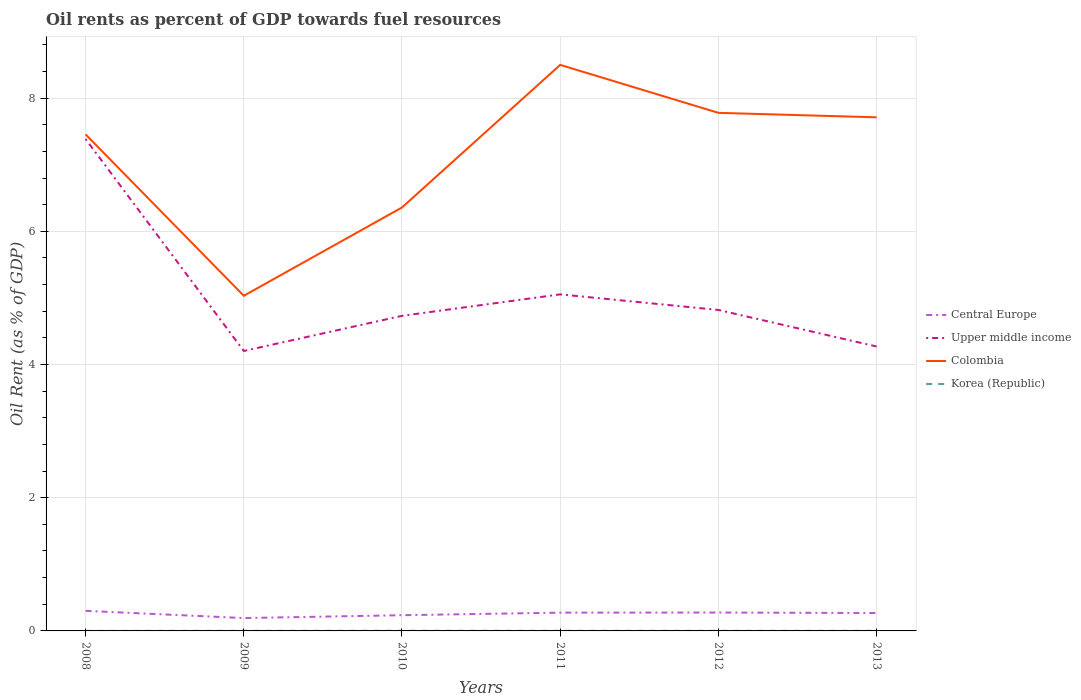How many different coloured lines are there?
Offer a very short reply. 4. Does the line corresponding to Colombia intersect with the line corresponding to Upper middle income?
Provide a short and direct response. No. Is the number of lines equal to the number of legend labels?
Ensure brevity in your answer.  Yes. Across all years, what is the maximum oil rent in Central Europe?
Provide a succinct answer. 0.19. In which year was the oil rent in Korea (Republic) maximum?
Provide a succinct answer. 2008. What is the total oil rent in Central Europe in the graph?
Your response must be concise. 0.01. What is the difference between the highest and the second highest oil rent in Korea (Republic)?
Provide a short and direct response. 0. What is the difference between the highest and the lowest oil rent in Central Europe?
Offer a very short reply. 4. Is the oil rent in Upper middle income strictly greater than the oil rent in Korea (Republic) over the years?
Your answer should be very brief. No. Are the values on the major ticks of Y-axis written in scientific E-notation?
Provide a succinct answer. No. Does the graph contain any zero values?
Ensure brevity in your answer.  No. How many legend labels are there?
Keep it short and to the point. 4. How are the legend labels stacked?
Provide a short and direct response. Vertical. What is the title of the graph?
Make the answer very short. Oil rents as percent of GDP towards fuel resources. Does "Benin" appear as one of the legend labels in the graph?
Provide a short and direct response. No. What is the label or title of the X-axis?
Your response must be concise. Years. What is the label or title of the Y-axis?
Your answer should be compact. Oil Rent (as % of GDP). What is the Oil Rent (as % of GDP) of Central Europe in 2008?
Provide a short and direct response. 0.3. What is the Oil Rent (as % of GDP) of Upper middle income in 2008?
Offer a very short reply. 7.39. What is the Oil Rent (as % of GDP) of Colombia in 2008?
Offer a very short reply. 7.46. What is the Oil Rent (as % of GDP) in Korea (Republic) in 2008?
Make the answer very short. 0. What is the Oil Rent (as % of GDP) in Central Europe in 2009?
Offer a terse response. 0.19. What is the Oil Rent (as % of GDP) in Upper middle income in 2009?
Ensure brevity in your answer.  4.2. What is the Oil Rent (as % of GDP) in Colombia in 2009?
Your response must be concise. 5.03. What is the Oil Rent (as % of GDP) of Korea (Republic) in 2009?
Provide a short and direct response. 0. What is the Oil Rent (as % of GDP) of Central Europe in 2010?
Your answer should be compact. 0.24. What is the Oil Rent (as % of GDP) in Upper middle income in 2010?
Provide a short and direct response. 4.73. What is the Oil Rent (as % of GDP) in Colombia in 2010?
Your answer should be compact. 6.36. What is the Oil Rent (as % of GDP) of Korea (Republic) in 2010?
Your answer should be very brief. 0. What is the Oil Rent (as % of GDP) in Central Europe in 2011?
Your response must be concise. 0.27. What is the Oil Rent (as % of GDP) of Upper middle income in 2011?
Provide a short and direct response. 5.05. What is the Oil Rent (as % of GDP) of Colombia in 2011?
Ensure brevity in your answer.  8.5. What is the Oil Rent (as % of GDP) of Korea (Republic) in 2011?
Offer a very short reply. 0. What is the Oil Rent (as % of GDP) in Central Europe in 2012?
Provide a short and direct response. 0.28. What is the Oil Rent (as % of GDP) in Upper middle income in 2012?
Your response must be concise. 4.82. What is the Oil Rent (as % of GDP) of Colombia in 2012?
Offer a terse response. 7.78. What is the Oil Rent (as % of GDP) of Korea (Republic) in 2012?
Make the answer very short. 0. What is the Oil Rent (as % of GDP) of Central Europe in 2013?
Offer a very short reply. 0.27. What is the Oil Rent (as % of GDP) in Upper middle income in 2013?
Your answer should be very brief. 4.27. What is the Oil Rent (as % of GDP) of Colombia in 2013?
Ensure brevity in your answer.  7.71. What is the Oil Rent (as % of GDP) of Korea (Republic) in 2013?
Your answer should be very brief. 0. Across all years, what is the maximum Oil Rent (as % of GDP) in Central Europe?
Your answer should be very brief. 0.3. Across all years, what is the maximum Oil Rent (as % of GDP) in Upper middle income?
Keep it short and to the point. 7.39. Across all years, what is the maximum Oil Rent (as % of GDP) in Colombia?
Offer a very short reply. 8.5. Across all years, what is the maximum Oil Rent (as % of GDP) of Korea (Republic)?
Provide a short and direct response. 0. Across all years, what is the minimum Oil Rent (as % of GDP) in Central Europe?
Keep it short and to the point. 0.19. Across all years, what is the minimum Oil Rent (as % of GDP) of Upper middle income?
Provide a succinct answer. 4.2. Across all years, what is the minimum Oil Rent (as % of GDP) in Colombia?
Your answer should be compact. 5.03. Across all years, what is the minimum Oil Rent (as % of GDP) in Korea (Republic)?
Offer a terse response. 0. What is the total Oil Rent (as % of GDP) of Central Europe in the graph?
Give a very brief answer. 1.55. What is the total Oil Rent (as % of GDP) of Upper middle income in the graph?
Your response must be concise. 30.46. What is the total Oil Rent (as % of GDP) in Colombia in the graph?
Your response must be concise. 42.83. What is the total Oil Rent (as % of GDP) in Korea (Republic) in the graph?
Offer a very short reply. 0.01. What is the difference between the Oil Rent (as % of GDP) in Central Europe in 2008 and that in 2009?
Offer a very short reply. 0.11. What is the difference between the Oil Rent (as % of GDP) in Upper middle income in 2008 and that in 2009?
Provide a short and direct response. 3.18. What is the difference between the Oil Rent (as % of GDP) in Colombia in 2008 and that in 2009?
Your answer should be very brief. 2.42. What is the difference between the Oil Rent (as % of GDP) of Korea (Republic) in 2008 and that in 2009?
Provide a short and direct response. -0. What is the difference between the Oil Rent (as % of GDP) of Central Europe in 2008 and that in 2010?
Offer a terse response. 0.07. What is the difference between the Oil Rent (as % of GDP) of Upper middle income in 2008 and that in 2010?
Your answer should be very brief. 2.65. What is the difference between the Oil Rent (as % of GDP) of Colombia in 2008 and that in 2010?
Give a very brief answer. 1.1. What is the difference between the Oil Rent (as % of GDP) in Korea (Republic) in 2008 and that in 2010?
Your answer should be very brief. -0. What is the difference between the Oil Rent (as % of GDP) in Central Europe in 2008 and that in 2011?
Your answer should be compact. 0.03. What is the difference between the Oil Rent (as % of GDP) of Upper middle income in 2008 and that in 2011?
Your answer should be very brief. 2.33. What is the difference between the Oil Rent (as % of GDP) in Colombia in 2008 and that in 2011?
Ensure brevity in your answer.  -1.04. What is the difference between the Oil Rent (as % of GDP) in Korea (Republic) in 2008 and that in 2011?
Keep it short and to the point. -0. What is the difference between the Oil Rent (as % of GDP) of Central Europe in 2008 and that in 2012?
Give a very brief answer. 0.03. What is the difference between the Oil Rent (as % of GDP) of Upper middle income in 2008 and that in 2012?
Offer a terse response. 2.57. What is the difference between the Oil Rent (as % of GDP) of Colombia in 2008 and that in 2012?
Offer a very short reply. -0.32. What is the difference between the Oil Rent (as % of GDP) in Korea (Republic) in 2008 and that in 2012?
Your response must be concise. -0. What is the difference between the Oil Rent (as % of GDP) of Central Europe in 2008 and that in 2013?
Keep it short and to the point. 0.03. What is the difference between the Oil Rent (as % of GDP) of Upper middle income in 2008 and that in 2013?
Make the answer very short. 3.12. What is the difference between the Oil Rent (as % of GDP) of Colombia in 2008 and that in 2013?
Ensure brevity in your answer.  -0.26. What is the difference between the Oil Rent (as % of GDP) in Korea (Republic) in 2008 and that in 2013?
Offer a terse response. -0. What is the difference between the Oil Rent (as % of GDP) in Central Europe in 2009 and that in 2010?
Your answer should be compact. -0.04. What is the difference between the Oil Rent (as % of GDP) in Upper middle income in 2009 and that in 2010?
Provide a succinct answer. -0.53. What is the difference between the Oil Rent (as % of GDP) in Colombia in 2009 and that in 2010?
Provide a short and direct response. -1.33. What is the difference between the Oil Rent (as % of GDP) in Korea (Republic) in 2009 and that in 2010?
Offer a very short reply. -0. What is the difference between the Oil Rent (as % of GDP) in Central Europe in 2009 and that in 2011?
Give a very brief answer. -0.08. What is the difference between the Oil Rent (as % of GDP) in Upper middle income in 2009 and that in 2011?
Offer a very short reply. -0.85. What is the difference between the Oil Rent (as % of GDP) of Colombia in 2009 and that in 2011?
Give a very brief answer. -3.47. What is the difference between the Oil Rent (as % of GDP) of Korea (Republic) in 2009 and that in 2011?
Give a very brief answer. -0. What is the difference between the Oil Rent (as % of GDP) in Central Europe in 2009 and that in 2012?
Your response must be concise. -0.08. What is the difference between the Oil Rent (as % of GDP) in Upper middle income in 2009 and that in 2012?
Provide a succinct answer. -0.62. What is the difference between the Oil Rent (as % of GDP) in Colombia in 2009 and that in 2012?
Give a very brief answer. -2.75. What is the difference between the Oil Rent (as % of GDP) in Korea (Republic) in 2009 and that in 2012?
Provide a short and direct response. -0. What is the difference between the Oil Rent (as % of GDP) of Central Europe in 2009 and that in 2013?
Give a very brief answer. -0.08. What is the difference between the Oil Rent (as % of GDP) of Upper middle income in 2009 and that in 2013?
Offer a very short reply. -0.07. What is the difference between the Oil Rent (as % of GDP) in Colombia in 2009 and that in 2013?
Provide a succinct answer. -2.68. What is the difference between the Oil Rent (as % of GDP) in Korea (Republic) in 2009 and that in 2013?
Offer a terse response. -0. What is the difference between the Oil Rent (as % of GDP) of Central Europe in 2010 and that in 2011?
Give a very brief answer. -0.04. What is the difference between the Oil Rent (as % of GDP) of Upper middle income in 2010 and that in 2011?
Give a very brief answer. -0.32. What is the difference between the Oil Rent (as % of GDP) in Colombia in 2010 and that in 2011?
Your answer should be very brief. -2.14. What is the difference between the Oil Rent (as % of GDP) of Central Europe in 2010 and that in 2012?
Provide a short and direct response. -0.04. What is the difference between the Oil Rent (as % of GDP) in Upper middle income in 2010 and that in 2012?
Give a very brief answer. -0.09. What is the difference between the Oil Rent (as % of GDP) in Colombia in 2010 and that in 2012?
Make the answer very short. -1.42. What is the difference between the Oil Rent (as % of GDP) in Korea (Republic) in 2010 and that in 2012?
Your answer should be very brief. 0. What is the difference between the Oil Rent (as % of GDP) in Central Europe in 2010 and that in 2013?
Keep it short and to the point. -0.03. What is the difference between the Oil Rent (as % of GDP) of Upper middle income in 2010 and that in 2013?
Keep it short and to the point. 0.46. What is the difference between the Oil Rent (as % of GDP) in Colombia in 2010 and that in 2013?
Your answer should be compact. -1.35. What is the difference between the Oil Rent (as % of GDP) of Korea (Republic) in 2010 and that in 2013?
Provide a short and direct response. 0. What is the difference between the Oil Rent (as % of GDP) of Central Europe in 2011 and that in 2012?
Offer a very short reply. -0. What is the difference between the Oil Rent (as % of GDP) of Upper middle income in 2011 and that in 2012?
Your answer should be compact. 0.23. What is the difference between the Oil Rent (as % of GDP) in Colombia in 2011 and that in 2012?
Offer a very short reply. 0.72. What is the difference between the Oil Rent (as % of GDP) in Korea (Republic) in 2011 and that in 2012?
Ensure brevity in your answer.  0. What is the difference between the Oil Rent (as % of GDP) in Central Europe in 2011 and that in 2013?
Your response must be concise. 0.01. What is the difference between the Oil Rent (as % of GDP) of Upper middle income in 2011 and that in 2013?
Give a very brief answer. 0.78. What is the difference between the Oil Rent (as % of GDP) of Colombia in 2011 and that in 2013?
Give a very brief answer. 0.79. What is the difference between the Oil Rent (as % of GDP) in Korea (Republic) in 2011 and that in 2013?
Offer a very short reply. 0. What is the difference between the Oil Rent (as % of GDP) in Central Europe in 2012 and that in 2013?
Offer a very short reply. 0.01. What is the difference between the Oil Rent (as % of GDP) of Upper middle income in 2012 and that in 2013?
Offer a terse response. 0.55. What is the difference between the Oil Rent (as % of GDP) of Colombia in 2012 and that in 2013?
Ensure brevity in your answer.  0.07. What is the difference between the Oil Rent (as % of GDP) of Central Europe in 2008 and the Oil Rent (as % of GDP) of Upper middle income in 2009?
Offer a very short reply. -3.9. What is the difference between the Oil Rent (as % of GDP) of Central Europe in 2008 and the Oil Rent (as % of GDP) of Colombia in 2009?
Provide a short and direct response. -4.73. What is the difference between the Oil Rent (as % of GDP) in Central Europe in 2008 and the Oil Rent (as % of GDP) in Korea (Republic) in 2009?
Provide a short and direct response. 0.3. What is the difference between the Oil Rent (as % of GDP) in Upper middle income in 2008 and the Oil Rent (as % of GDP) in Colombia in 2009?
Make the answer very short. 2.35. What is the difference between the Oil Rent (as % of GDP) of Upper middle income in 2008 and the Oil Rent (as % of GDP) of Korea (Republic) in 2009?
Your answer should be compact. 7.38. What is the difference between the Oil Rent (as % of GDP) of Colombia in 2008 and the Oil Rent (as % of GDP) of Korea (Republic) in 2009?
Ensure brevity in your answer.  7.45. What is the difference between the Oil Rent (as % of GDP) of Central Europe in 2008 and the Oil Rent (as % of GDP) of Upper middle income in 2010?
Make the answer very short. -4.43. What is the difference between the Oil Rent (as % of GDP) of Central Europe in 2008 and the Oil Rent (as % of GDP) of Colombia in 2010?
Provide a short and direct response. -6.06. What is the difference between the Oil Rent (as % of GDP) of Central Europe in 2008 and the Oil Rent (as % of GDP) of Korea (Republic) in 2010?
Your answer should be compact. 0.3. What is the difference between the Oil Rent (as % of GDP) of Upper middle income in 2008 and the Oil Rent (as % of GDP) of Colombia in 2010?
Your response must be concise. 1.03. What is the difference between the Oil Rent (as % of GDP) in Upper middle income in 2008 and the Oil Rent (as % of GDP) in Korea (Republic) in 2010?
Your answer should be very brief. 7.38. What is the difference between the Oil Rent (as % of GDP) of Colombia in 2008 and the Oil Rent (as % of GDP) of Korea (Republic) in 2010?
Give a very brief answer. 7.45. What is the difference between the Oil Rent (as % of GDP) of Central Europe in 2008 and the Oil Rent (as % of GDP) of Upper middle income in 2011?
Give a very brief answer. -4.75. What is the difference between the Oil Rent (as % of GDP) of Central Europe in 2008 and the Oil Rent (as % of GDP) of Colombia in 2011?
Keep it short and to the point. -8.2. What is the difference between the Oil Rent (as % of GDP) in Central Europe in 2008 and the Oil Rent (as % of GDP) in Korea (Republic) in 2011?
Provide a short and direct response. 0.3. What is the difference between the Oil Rent (as % of GDP) of Upper middle income in 2008 and the Oil Rent (as % of GDP) of Colombia in 2011?
Ensure brevity in your answer.  -1.11. What is the difference between the Oil Rent (as % of GDP) in Upper middle income in 2008 and the Oil Rent (as % of GDP) in Korea (Republic) in 2011?
Your answer should be compact. 7.38. What is the difference between the Oil Rent (as % of GDP) of Colombia in 2008 and the Oil Rent (as % of GDP) of Korea (Republic) in 2011?
Your answer should be very brief. 7.45. What is the difference between the Oil Rent (as % of GDP) of Central Europe in 2008 and the Oil Rent (as % of GDP) of Upper middle income in 2012?
Provide a succinct answer. -4.52. What is the difference between the Oil Rent (as % of GDP) in Central Europe in 2008 and the Oil Rent (as % of GDP) in Colombia in 2012?
Offer a very short reply. -7.48. What is the difference between the Oil Rent (as % of GDP) in Central Europe in 2008 and the Oil Rent (as % of GDP) in Korea (Republic) in 2012?
Provide a succinct answer. 0.3. What is the difference between the Oil Rent (as % of GDP) of Upper middle income in 2008 and the Oil Rent (as % of GDP) of Colombia in 2012?
Ensure brevity in your answer.  -0.39. What is the difference between the Oil Rent (as % of GDP) in Upper middle income in 2008 and the Oil Rent (as % of GDP) in Korea (Republic) in 2012?
Provide a short and direct response. 7.38. What is the difference between the Oil Rent (as % of GDP) in Colombia in 2008 and the Oil Rent (as % of GDP) in Korea (Republic) in 2012?
Provide a succinct answer. 7.45. What is the difference between the Oil Rent (as % of GDP) in Central Europe in 2008 and the Oil Rent (as % of GDP) in Upper middle income in 2013?
Your answer should be compact. -3.97. What is the difference between the Oil Rent (as % of GDP) in Central Europe in 2008 and the Oil Rent (as % of GDP) in Colombia in 2013?
Your response must be concise. -7.41. What is the difference between the Oil Rent (as % of GDP) in Central Europe in 2008 and the Oil Rent (as % of GDP) in Korea (Republic) in 2013?
Provide a succinct answer. 0.3. What is the difference between the Oil Rent (as % of GDP) in Upper middle income in 2008 and the Oil Rent (as % of GDP) in Colombia in 2013?
Keep it short and to the point. -0.33. What is the difference between the Oil Rent (as % of GDP) in Upper middle income in 2008 and the Oil Rent (as % of GDP) in Korea (Republic) in 2013?
Provide a succinct answer. 7.38. What is the difference between the Oil Rent (as % of GDP) of Colombia in 2008 and the Oil Rent (as % of GDP) of Korea (Republic) in 2013?
Offer a very short reply. 7.45. What is the difference between the Oil Rent (as % of GDP) of Central Europe in 2009 and the Oil Rent (as % of GDP) of Upper middle income in 2010?
Make the answer very short. -4.54. What is the difference between the Oil Rent (as % of GDP) in Central Europe in 2009 and the Oil Rent (as % of GDP) in Colombia in 2010?
Offer a terse response. -6.16. What is the difference between the Oil Rent (as % of GDP) in Central Europe in 2009 and the Oil Rent (as % of GDP) in Korea (Republic) in 2010?
Give a very brief answer. 0.19. What is the difference between the Oil Rent (as % of GDP) in Upper middle income in 2009 and the Oil Rent (as % of GDP) in Colombia in 2010?
Keep it short and to the point. -2.15. What is the difference between the Oil Rent (as % of GDP) in Upper middle income in 2009 and the Oil Rent (as % of GDP) in Korea (Republic) in 2010?
Offer a very short reply. 4.2. What is the difference between the Oil Rent (as % of GDP) in Colombia in 2009 and the Oil Rent (as % of GDP) in Korea (Republic) in 2010?
Your response must be concise. 5.03. What is the difference between the Oil Rent (as % of GDP) of Central Europe in 2009 and the Oil Rent (as % of GDP) of Upper middle income in 2011?
Provide a short and direct response. -4.86. What is the difference between the Oil Rent (as % of GDP) in Central Europe in 2009 and the Oil Rent (as % of GDP) in Colombia in 2011?
Give a very brief answer. -8.31. What is the difference between the Oil Rent (as % of GDP) in Central Europe in 2009 and the Oil Rent (as % of GDP) in Korea (Republic) in 2011?
Ensure brevity in your answer.  0.19. What is the difference between the Oil Rent (as % of GDP) in Upper middle income in 2009 and the Oil Rent (as % of GDP) in Colombia in 2011?
Offer a very short reply. -4.3. What is the difference between the Oil Rent (as % of GDP) in Upper middle income in 2009 and the Oil Rent (as % of GDP) in Korea (Republic) in 2011?
Ensure brevity in your answer.  4.2. What is the difference between the Oil Rent (as % of GDP) in Colombia in 2009 and the Oil Rent (as % of GDP) in Korea (Republic) in 2011?
Offer a terse response. 5.03. What is the difference between the Oil Rent (as % of GDP) in Central Europe in 2009 and the Oil Rent (as % of GDP) in Upper middle income in 2012?
Give a very brief answer. -4.63. What is the difference between the Oil Rent (as % of GDP) of Central Europe in 2009 and the Oil Rent (as % of GDP) of Colombia in 2012?
Make the answer very short. -7.59. What is the difference between the Oil Rent (as % of GDP) of Central Europe in 2009 and the Oil Rent (as % of GDP) of Korea (Republic) in 2012?
Give a very brief answer. 0.19. What is the difference between the Oil Rent (as % of GDP) in Upper middle income in 2009 and the Oil Rent (as % of GDP) in Colombia in 2012?
Provide a succinct answer. -3.58. What is the difference between the Oil Rent (as % of GDP) of Upper middle income in 2009 and the Oil Rent (as % of GDP) of Korea (Republic) in 2012?
Offer a very short reply. 4.2. What is the difference between the Oil Rent (as % of GDP) in Colombia in 2009 and the Oil Rent (as % of GDP) in Korea (Republic) in 2012?
Offer a terse response. 5.03. What is the difference between the Oil Rent (as % of GDP) of Central Europe in 2009 and the Oil Rent (as % of GDP) of Upper middle income in 2013?
Offer a terse response. -4.08. What is the difference between the Oil Rent (as % of GDP) in Central Europe in 2009 and the Oil Rent (as % of GDP) in Colombia in 2013?
Provide a short and direct response. -7.52. What is the difference between the Oil Rent (as % of GDP) of Central Europe in 2009 and the Oil Rent (as % of GDP) of Korea (Republic) in 2013?
Your answer should be compact. 0.19. What is the difference between the Oil Rent (as % of GDP) in Upper middle income in 2009 and the Oil Rent (as % of GDP) in Colombia in 2013?
Your answer should be compact. -3.51. What is the difference between the Oil Rent (as % of GDP) in Upper middle income in 2009 and the Oil Rent (as % of GDP) in Korea (Republic) in 2013?
Your answer should be very brief. 4.2. What is the difference between the Oil Rent (as % of GDP) of Colombia in 2009 and the Oil Rent (as % of GDP) of Korea (Republic) in 2013?
Offer a very short reply. 5.03. What is the difference between the Oil Rent (as % of GDP) in Central Europe in 2010 and the Oil Rent (as % of GDP) in Upper middle income in 2011?
Ensure brevity in your answer.  -4.82. What is the difference between the Oil Rent (as % of GDP) of Central Europe in 2010 and the Oil Rent (as % of GDP) of Colombia in 2011?
Give a very brief answer. -8.26. What is the difference between the Oil Rent (as % of GDP) of Central Europe in 2010 and the Oil Rent (as % of GDP) of Korea (Republic) in 2011?
Make the answer very short. 0.23. What is the difference between the Oil Rent (as % of GDP) of Upper middle income in 2010 and the Oil Rent (as % of GDP) of Colombia in 2011?
Ensure brevity in your answer.  -3.77. What is the difference between the Oil Rent (as % of GDP) of Upper middle income in 2010 and the Oil Rent (as % of GDP) of Korea (Republic) in 2011?
Make the answer very short. 4.73. What is the difference between the Oil Rent (as % of GDP) of Colombia in 2010 and the Oil Rent (as % of GDP) of Korea (Republic) in 2011?
Provide a short and direct response. 6.36. What is the difference between the Oil Rent (as % of GDP) in Central Europe in 2010 and the Oil Rent (as % of GDP) in Upper middle income in 2012?
Offer a terse response. -4.58. What is the difference between the Oil Rent (as % of GDP) of Central Europe in 2010 and the Oil Rent (as % of GDP) of Colombia in 2012?
Ensure brevity in your answer.  -7.54. What is the difference between the Oil Rent (as % of GDP) of Central Europe in 2010 and the Oil Rent (as % of GDP) of Korea (Republic) in 2012?
Provide a short and direct response. 0.23. What is the difference between the Oil Rent (as % of GDP) of Upper middle income in 2010 and the Oil Rent (as % of GDP) of Colombia in 2012?
Your answer should be compact. -3.05. What is the difference between the Oil Rent (as % of GDP) of Upper middle income in 2010 and the Oil Rent (as % of GDP) of Korea (Republic) in 2012?
Your answer should be compact. 4.73. What is the difference between the Oil Rent (as % of GDP) in Colombia in 2010 and the Oil Rent (as % of GDP) in Korea (Republic) in 2012?
Offer a very short reply. 6.36. What is the difference between the Oil Rent (as % of GDP) of Central Europe in 2010 and the Oil Rent (as % of GDP) of Upper middle income in 2013?
Your response must be concise. -4.03. What is the difference between the Oil Rent (as % of GDP) in Central Europe in 2010 and the Oil Rent (as % of GDP) in Colombia in 2013?
Keep it short and to the point. -7.48. What is the difference between the Oil Rent (as % of GDP) in Central Europe in 2010 and the Oil Rent (as % of GDP) in Korea (Republic) in 2013?
Offer a very short reply. 0.23. What is the difference between the Oil Rent (as % of GDP) in Upper middle income in 2010 and the Oil Rent (as % of GDP) in Colombia in 2013?
Your answer should be compact. -2.98. What is the difference between the Oil Rent (as % of GDP) in Upper middle income in 2010 and the Oil Rent (as % of GDP) in Korea (Republic) in 2013?
Give a very brief answer. 4.73. What is the difference between the Oil Rent (as % of GDP) in Colombia in 2010 and the Oil Rent (as % of GDP) in Korea (Republic) in 2013?
Your response must be concise. 6.36. What is the difference between the Oil Rent (as % of GDP) in Central Europe in 2011 and the Oil Rent (as % of GDP) in Upper middle income in 2012?
Provide a succinct answer. -4.54. What is the difference between the Oil Rent (as % of GDP) in Central Europe in 2011 and the Oil Rent (as % of GDP) in Colombia in 2012?
Keep it short and to the point. -7.5. What is the difference between the Oil Rent (as % of GDP) of Central Europe in 2011 and the Oil Rent (as % of GDP) of Korea (Republic) in 2012?
Ensure brevity in your answer.  0.27. What is the difference between the Oil Rent (as % of GDP) in Upper middle income in 2011 and the Oil Rent (as % of GDP) in Colombia in 2012?
Offer a very short reply. -2.73. What is the difference between the Oil Rent (as % of GDP) of Upper middle income in 2011 and the Oil Rent (as % of GDP) of Korea (Republic) in 2012?
Provide a short and direct response. 5.05. What is the difference between the Oil Rent (as % of GDP) of Colombia in 2011 and the Oil Rent (as % of GDP) of Korea (Republic) in 2012?
Your response must be concise. 8.5. What is the difference between the Oil Rent (as % of GDP) in Central Europe in 2011 and the Oil Rent (as % of GDP) in Upper middle income in 2013?
Your response must be concise. -4. What is the difference between the Oil Rent (as % of GDP) of Central Europe in 2011 and the Oil Rent (as % of GDP) of Colombia in 2013?
Offer a very short reply. -7.44. What is the difference between the Oil Rent (as % of GDP) of Central Europe in 2011 and the Oil Rent (as % of GDP) of Korea (Republic) in 2013?
Provide a succinct answer. 0.27. What is the difference between the Oil Rent (as % of GDP) of Upper middle income in 2011 and the Oil Rent (as % of GDP) of Colombia in 2013?
Offer a very short reply. -2.66. What is the difference between the Oil Rent (as % of GDP) of Upper middle income in 2011 and the Oil Rent (as % of GDP) of Korea (Republic) in 2013?
Provide a succinct answer. 5.05. What is the difference between the Oil Rent (as % of GDP) of Colombia in 2011 and the Oil Rent (as % of GDP) of Korea (Republic) in 2013?
Offer a terse response. 8.5. What is the difference between the Oil Rent (as % of GDP) in Central Europe in 2012 and the Oil Rent (as % of GDP) in Upper middle income in 2013?
Your answer should be compact. -3.99. What is the difference between the Oil Rent (as % of GDP) in Central Europe in 2012 and the Oil Rent (as % of GDP) in Colombia in 2013?
Provide a succinct answer. -7.44. What is the difference between the Oil Rent (as % of GDP) of Central Europe in 2012 and the Oil Rent (as % of GDP) of Korea (Republic) in 2013?
Provide a short and direct response. 0.27. What is the difference between the Oil Rent (as % of GDP) in Upper middle income in 2012 and the Oil Rent (as % of GDP) in Colombia in 2013?
Your response must be concise. -2.89. What is the difference between the Oil Rent (as % of GDP) in Upper middle income in 2012 and the Oil Rent (as % of GDP) in Korea (Republic) in 2013?
Keep it short and to the point. 4.82. What is the difference between the Oil Rent (as % of GDP) in Colombia in 2012 and the Oil Rent (as % of GDP) in Korea (Republic) in 2013?
Your answer should be compact. 7.78. What is the average Oil Rent (as % of GDP) of Central Europe per year?
Your answer should be very brief. 0.26. What is the average Oil Rent (as % of GDP) in Upper middle income per year?
Offer a terse response. 5.08. What is the average Oil Rent (as % of GDP) of Colombia per year?
Provide a short and direct response. 7.14. What is the average Oil Rent (as % of GDP) in Korea (Republic) per year?
Your response must be concise. 0. In the year 2008, what is the difference between the Oil Rent (as % of GDP) in Central Europe and Oil Rent (as % of GDP) in Upper middle income?
Your answer should be very brief. -7.08. In the year 2008, what is the difference between the Oil Rent (as % of GDP) of Central Europe and Oil Rent (as % of GDP) of Colombia?
Offer a terse response. -7.15. In the year 2008, what is the difference between the Oil Rent (as % of GDP) in Central Europe and Oil Rent (as % of GDP) in Korea (Republic)?
Ensure brevity in your answer.  0.3. In the year 2008, what is the difference between the Oil Rent (as % of GDP) of Upper middle income and Oil Rent (as % of GDP) of Colombia?
Your answer should be very brief. -0.07. In the year 2008, what is the difference between the Oil Rent (as % of GDP) of Upper middle income and Oil Rent (as % of GDP) of Korea (Republic)?
Offer a very short reply. 7.38. In the year 2008, what is the difference between the Oil Rent (as % of GDP) of Colombia and Oil Rent (as % of GDP) of Korea (Republic)?
Your answer should be compact. 7.45. In the year 2009, what is the difference between the Oil Rent (as % of GDP) in Central Europe and Oil Rent (as % of GDP) in Upper middle income?
Offer a very short reply. -4.01. In the year 2009, what is the difference between the Oil Rent (as % of GDP) of Central Europe and Oil Rent (as % of GDP) of Colombia?
Give a very brief answer. -4.84. In the year 2009, what is the difference between the Oil Rent (as % of GDP) of Central Europe and Oil Rent (as % of GDP) of Korea (Republic)?
Your response must be concise. 0.19. In the year 2009, what is the difference between the Oil Rent (as % of GDP) in Upper middle income and Oil Rent (as % of GDP) in Colombia?
Your response must be concise. -0.83. In the year 2009, what is the difference between the Oil Rent (as % of GDP) of Upper middle income and Oil Rent (as % of GDP) of Korea (Republic)?
Make the answer very short. 4.2. In the year 2009, what is the difference between the Oil Rent (as % of GDP) of Colombia and Oil Rent (as % of GDP) of Korea (Republic)?
Your answer should be compact. 5.03. In the year 2010, what is the difference between the Oil Rent (as % of GDP) in Central Europe and Oil Rent (as % of GDP) in Upper middle income?
Ensure brevity in your answer.  -4.5. In the year 2010, what is the difference between the Oil Rent (as % of GDP) in Central Europe and Oil Rent (as % of GDP) in Colombia?
Your response must be concise. -6.12. In the year 2010, what is the difference between the Oil Rent (as % of GDP) of Central Europe and Oil Rent (as % of GDP) of Korea (Republic)?
Your answer should be very brief. 0.23. In the year 2010, what is the difference between the Oil Rent (as % of GDP) of Upper middle income and Oil Rent (as % of GDP) of Colombia?
Your answer should be very brief. -1.63. In the year 2010, what is the difference between the Oil Rent (as % of GDP) in Upper middle income and Oil Rent (as % of GDP) in Korea (Republic)?
Offer a very short reply. 4.73. In the year 2010, what is the difference between the Oil Rent (as % of GDP) in Colombia and Oil Rent (as % of GDP) in Korea (Republic)?
Offer a terse response. 6.36. In the year 2011, what is the difference between the Oil Rent (as % of GDP) of Central Europe and Oil Rent (as % of GDP) of Upper middle income?
Provide a succinct answer. -4.78. In the year 2011, what is the difference between the Oil Rent (as % of GDP) of Central Europe and Oil Rent (as % of GDP) of Colombia?
Make the answer very short. -8.22. In the year 2011, what is the difference between the Oil Rent (as % of GDP) of Central Europe and Oil Rent (as % of GDP) of Korea (Republic)?
Give a very brief answer. 0.27. In the year 2011, what is the difference between the Oil Rent (as % of GDP) of Upper middle income and Oil Rent (as % of GDP) of Colombia?
Your answer should be very brief. -3.45. In the year 2011, what is the difference between the Oil Rent (as % of GDP) of Upper middle income and Oil Rent (as % of GDP) of Korea (Republic)?
Ensure brevity in your answer.  5.05. In the year 2011, what is the difference between the Oil Rent (as % of GDP) of Colombia and Oil Rent (as % of GDP) of Korea (Republic)?
Give a very brief answer. 8.5. In the year 2012, what is the difference between the Oil Rent (as % of GDP) of Central Europe and Oil Rent (as % of GDP) of Upper middle income?
Provide a succinct answer. -4.54. In the year 2012, what is the difference between the Oil Rent (as % of GDP) in Central Europe and Oil Rent (as % of GDP) in Colombia?
Ensure brevity in your answer.  -7.5. In the year 2012, what is the difference between the Oil Rent (as % of GDP) in Central Europe and Oil Rent (as % of GDP) in Korea (Republic)?
Your answer should be very brief. 0.27. In the year 2012, what is the difference between the Oil Rent (as % of GDP) in Upper middle income and Oil Rent (as % of GDP) in Colombia?
Keep it short and to the point. -2.96. In the year 2012, what is the difference between the Oil Rent (as % of GDP) of Upper middle income and Oil Rent (as % of GDP) of Korea (Republic)?
Make the answer very short. 4.82. In the year 2012, what is the difference between the Oil Rent (as % of GDP) in Colombia and Oil Rent (as % of GDP) in Korea (Republic)?
Give a very brief answer. 7.78. In the year 2013, what is the difference between the Oil Rent (as % of GDP) of Central Europe and Oil Rent (as % of GDP) of Upper middle income?
Your answer should be very brief. -4. In the year 2013, what is the difference between the Oil Rent (as % of GDP) of Central Europe and Oil Rent (as % of GDP) of Colombia?
Your answer should be compact. -7.44. In the year 2013, what is the difference between the Oil Rent (as % of GDP) of Central Europe and Oil Rent (as % of GDP) of Korea (Republic)?
Your answer should be compact. 0.27. In the year 2013, what is the difference between the Oil Rent (as % of GDP) in Upper middle income and Oil Rent (as % of GDP) in Colombia?
Make the answer very short. -3.44. In the year 2013, what is the difference between the Oil Rent (as % of GDP) of Upper middle income and Oil Rent (as % of GDP) of Korea (Republic)?
Your answer should be compact. 4.27. In the year 2013, what is the difference between the Oil Rent (as % of GDP) in Colombia and Oil Rent (as % of GDP) in Korea (Republic)?
Your response must be concise. 7.71. What is the ratio of the Oil Rent (as % of GDP) in Central Europe in 2008 to that in 2009?
Provide a succinct answer. 1.56. What is the ratio of the Oil Rent (as % of GDP) in Upper middle income in 2008 to that in 2009?
Your response must be concise. 1.76. What is the ratio of the Oil Rent (as % of GDP) of Colombia in 2008 to that in 2009?
Provide a succinct answer. 1.48. What is the ratio of the Oil Rent (as % of GDP) in Korea (Republic) in 2008 to that in 2009?
Keep it short and to the point. 0.77. What is the ratio of the Oil Rent (as % of GDP) of Central Europe in 2008 to that in 2010?
Your answer should be compact. 1.28. What is the ratio of the Oil Rent (as % of GDP) of Upper middle income in 2008 to that in 2010?
Give a very brief answer. 1.56. What is the ratio of the Oil Rent (as % of GDP) of Colombia in 2008 to that in 2010?
Keep it short and to the point. 1.17. What is the ratio of the Oil Rent (as % of GDP) of Korea (Republic) in 2008 to that in 2010?
Keep it short and to the point. 0.56. What is the ratio of the Oil Rent (as % of GDP) of Central Europe in 2008 to that in 2011?
Your answer should be very brief. 1.1. What is the ratio of the Oil Rent (as % of GDP) in Upper middle income in 2008 to that in 2011?
Make the answer very short. 1.46. What is the ratio of the Oil Rent (as % of GDP) in Colombia in 2008 to that in 2011?
Provide a short and direct response. 0.88. What is the ratio of the Oil Rent (as % of GDP) of Korea (Republic) in 2008 to that in 2011?
Provide a succinct answer. 0.63. What is the ratio of the Oil Rent (as % of GDP) in Central Europe in 2008 to that in 2012?
Your response must be concise. 1.09. What is the ratio of the Oil Rent (as % of GDP) in Upper middle income in 2008 to that in 2012?
Your response must be concise. 1.53. What is the ratio of the Oil Rent (as % of GDP) in Colombia in 2008 to that in 2012?
Your response must be concise. 0.96. What is the ratio of the Oil Rent (as % of GDP) of Korea (Republic) in 2008 to that in 2012?
Your answer should be very brief. 0.71. What is the ratio of the Oil Rent (as % of GDP) of Central Europe in 2008 to that in 2013?
Give a very brief answer. 1.12. What is the ratio of the Oil Rent (as % of GDP) in Upper middle income in 2008 to that in 2013?
Your response must be concise. 1.73. What is the ratio of the Oil Rent (as % of GDP) of Colombia in 2008 to that in 2013?
Offer a terse response. 0.97. What is the ratio of the Oil Rent (as % of GDP) in Korea (Republic) in 2008 to that in 2013?
Offer a terse response. 0.7. What is the ratio of the Oil Rent (as % of GDP) of Central Europe in 2009 to that in 2010?
Provide a short and direct response. 0.82. What is the ratio of the Oil Rent (as % of GDP) in Upper middle income in 2009 to that in 2010?
Give a very brief answer. 0.89. What is the ratio of the Oil Rent (as % of GDP) in Colombia in 2009 to that in 2010?
Keep it short and to the point. 0.79. What is the ratio of the Oil Rent (as % of GDP) of Korea (Republic) in 2009 to that in 2010?
Ensure brevity in your answer.  0.73. What is the ratio of the Oil Rent (as % of GDP) of Central Europe in 2009 to that in 2011?
Your answer should be very brief. 0.7. What is the ratio of the Oil Rent (as % of GDP) of Upper middle income in 2009 to that in 2011?
Your response must be concise. 0.83. What is the ratio of the Oil Rent (as % of GDP) in Colombia in 2009 to that in 2011?
Ensure brevity in your answer.  0.59. What is the ratio of the Oil Rent (as % of GDP) of Korea (Republic) in 2009 to that in 2011?
Provide a succinct answer. 0.82. What is the ratio of the Oil Rent (as % of GDP) of Central Europe in 2009 to that in 2012?
Your answer should be very brief. 0.7. What is the ratio of the Oil Rent (as % of GDP) in Upper middle income in 2009 to that in 2012?
Provide a short and direct response. 0.87. What is the ratio of the Oil Rent (as % of GDP) in Colombia in 2009 to that in 2012?
Make the answer very short. 0.65. What is the ratio of the Oil Rent (as % of GDP) of Korea (Republic) in 2009 to that in 2012?
Your answer should be very brief. 0.92. What is the ratio of the Oil Rent (as % of GDP) in Central Europe in 2009 to that in 2013?
Offer a very short reply. 0.72. What is the ratio of the Oil Rent (as % of GDP) of Upper middle income in 2009 to that in 2013?
Offer a terse response. 0.98. What is the ratio of the Oil Rent (as % of GDP) in Colombia in 2009 to that in 2013?
Offer a terse response. 0.65. What is the ratio of the Oil Rent (as % of GDP) in Korea (Republic) in 2009 to that in 2013?
Give a very brief answer. 0.91. What is the ratio of the Oil Rent (as % of GDP) of Central Europe in 2010 to that in 2011?
Your response must be concise. 0.86. What is the ratio of the Oil Rent (as % of GDP) of Upper middle income in 2010 to that in 2011?
Provide a short and direct response. 0.94. What is the ratio of the Oil Rent (as % of GDP) of Colombia in 2010 to that in 2011?
Offer a terse response. 0.75. What is the ratio of the Oil Rent (as % of GDP) of Korea (Republic) in 2010 to that in 2011?
Your answer should be compact. 1.12. What is the ratio of the Oil Rent (as % of GDP) in Central Europe in 2010 to that in 2012?
Provide a succinct answer. 0.85. What is the ratio of the Oil Rent (as % of GDP) in Upper middle income in 2010 to that in 2012?
Offer a terse response. 0.98. What is the ratio of the Oil Rent (as % of GDP) of Colombia in 2010 to that in 2012?
Ensure brevity in your answer.  0.82. What is the ratio of the Oil Rent (as % of GDP) in Korea (Republic) in 2010 to that in 2012?
Keep it short and to the point. 1.25. What is the ratio of the Oil Rent (as % of GDP) in Central Europe in 2010 to that in 2013?
Your response must be concise. 0.88. What is the ratio of the Oil Rent (as % of GDP) in Upper middle income in 2010 to that in 2013?
Offer a very short reply. 1.11. What is the ratio of the Oil Rent (as % of GDP) of Colombia in 2010 to that in 2013?
Make the answer very short. 0.82. What is the ratio of the Oil Rent (as % of GDP) in Korea (Republic) in 2010 to that in 2013?
Provide a short and direct response. 1.25. What is the ratio of the Oil Rent (as % of GDP) in Upper middle income in 2011 to that in 2012?
Provide a short and direct response. 1.05. What is the ratio of the Oil Rent (as % of GDP) of Colombia in 2011 to that in 2012?
Provide a succinct answer. 1.09. What is the ratio of the Oil Rent (as % of GDP) of Korea (Republic) in 2011 to that in 2012?
Your answer should be very brief. 1.12. What is the ratio of the Oil Rent (as % of GDP) in Central Europe in 2011 to that in 2013?
Your response must be concise. 1.02. What is the ratio of the Oil Rent (as % of GDP) in Upper middle income in 2011 to that in 2013?
Your answer should be very brief. 1.18. What is the ratio of the Oil Rent (as % of GDP) of Colombia in 2011 to that in 2013?
Give a very brief answer. 1.1. What is the ratio of the Oil Rent (as % of GDP) in Korea (Republic) in 2011 to that in 2013?
Provide a succinct answer. 1.11. What is the ratio of the Oil Rent (as % of GDP) of Central Europe in 2012 to that in 2013?
Keep it short and to the point. 1.03. What is the ratio of the Oil Rent (as % of GDP) in Upper middle income in 2012 to that in 2013?
Your answer should be compact. 1.13. What is the ratio of the Oil Rent (as % of GDP) of Colombia in 2012 to that in 2013?
Ensure brevity in your answer.  1.01. What is the ratio of the Oil Rent (as % of GDP) of Korea (Republic) in 2012 to that in 2013?
Provide a short and direct response. 1. What is the difference between the highest and the second highest Oil Rent (as % of GDP) of Central Europe?
Provide a short and direct response. 0.03. What is the difference between the highest and the second highest Oil Rent (as % of GDP) in Upper middle income?
Provide a short and direct response. 2.33. What is the difference between the highest and the second highest Oil Rent (as % of GDP) of Colombia?
Provide a short and direct response. 0.72. What is the difference between the highest and the lowest Oil Rent (as % of GDP) in Central Europe?
Provide a short and direct response. 0.11. What is the difference between the highest and the lowest Oil Rent (as % of GDP) in Upper middle income?
Your response must be concise. 3.18. What is the difference between the highest and the lowest Oil Rent (as % of GDP) of Colombia?
Give a very brief answer. 3.47. 